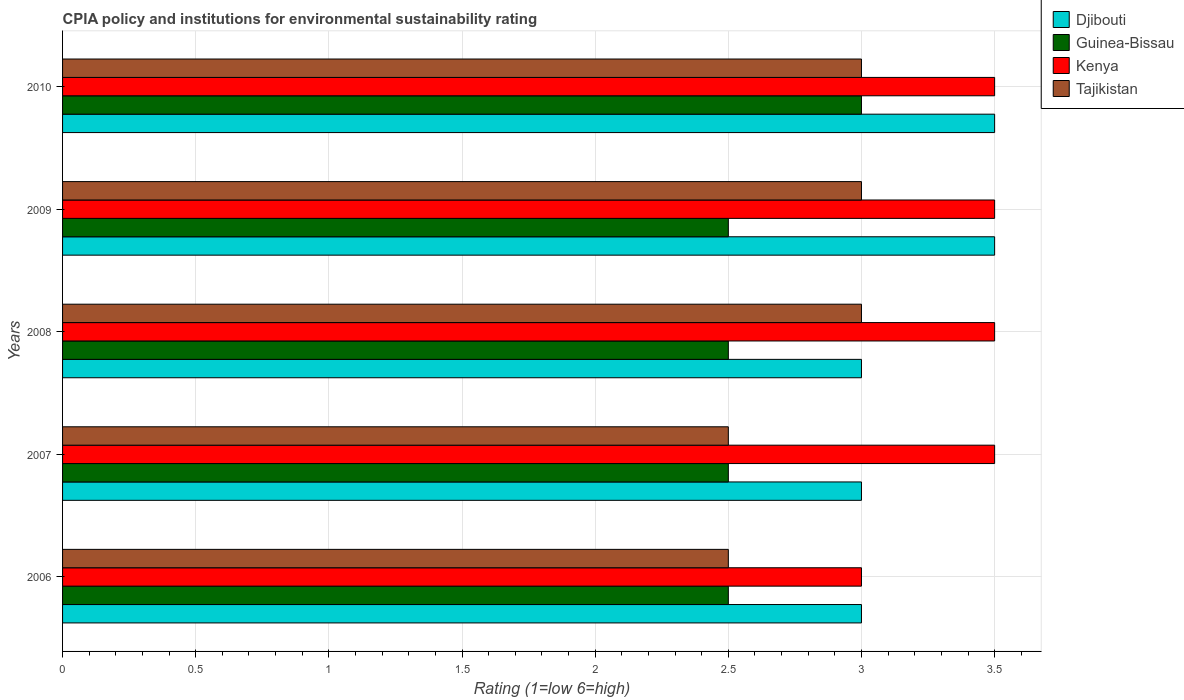How many different coloured bars are there?
Offer a terse response. 4. Are the number of bars per tick equal to the number of legend labels?
Offer a very short reply. Yes. Are the number of bars on each tick of the Y-axis equal?
Provide a succinct answer. Yes. How many bars are there on the 1st tick from the top?
Ensure brevity in your answer.  4. How many bars are there on the 2nd tick from the bottom?
Ensure brevity in your answer.  4. What is the label of the 1st group of bars from the top?
Provide a succinct answer. 2010. What is the CPIA rating in Kenya in 2009?
Your answer should be compact. 3.5. Across all years, what is the maximum CPIA rating in Tajikistan?
Make the answer very short. 3. Is the difference between the CPIA rating in Tajikistan in 2006 and 2007 greater than the difference between the CPIA rating in Guinea-Bissau in 2006 and 2007?
Offer a terse response. No. What is the difference between the highest and the second highest CPIA rating in Tajikistan?
Give a very brief answer. 0. What is the difference between the highest and the lowest CPIA rating in Kenya?
Your answer should be very brief. 0.5. Is it the case that in every year, the sum of the CPIA rating in Tajikistan and CPIA rating in Guinea-Bissau is greater than the sum of CPIA rating in Djibouti and CPIA rating in Kenya?
Provide a succinct answer. No. What does the 4th bar from the top in 2007 represents?
Keep it short and to the point. Djibouti. What does the 1st bar from the bottom in 2007 represents?
Provide a short and direct response. Djibouti. How many bars are there?
Keep it short and to the point. 20. Are all the bars in the graph horizontal?
Offer a terse response. Yes. What is the difference between two consecutive major ticks on the X-axis?
Provide a short and direct response. 0.5. Does the graph contain grids?
Your answer should be very brief. Yes. How many legend labels are there?
Ensure brevity in your answer.  4. How are the legend labels stacked?
Offer a terse response. Vertical. What is the title of the graph?
Offer a terse response. CPIA policy and institutions for environmental sustainability rating. Does "Honduras" appear as one of the legend labels in the graph?
Make the answer very short. No. What is the Rating (1=low 6=high) of Djibouti in 2006?
Your answer should be very brief. 3. What is the Rating (1=low 6=high) of Guinea-Bissau in 2006?
Keep it short and to the point. 2.5. What is the Rating (1=low 6=high) of Kenya in 2006?
Your answer should be compact. 3. What is the Rating (1=low 6=high) of Tajikistan in 2006?
Provide a succinct answer. 2.5. What is the Rating (1=low 6=high) in Djibouti in 2007?
Make the answer very short. 3. What is the Rating (1=low 6=high) in Kenya in 2008?
Offer a very short reply. 3.5. What is the Rating (1=low 6=high) of Kenya in 2009?
Provide a succinct answer. 3.5. What is the Rating (1=low 6=high) of Tajikistan in 2009?
Your response must be concise. 3. What is the Rating (1=low 6=high) in Djibouti in 2010?
Provide a succinct answer. 3.5. What is the Rating (1=low 6=high) of Tajikistan in 2010?
Give a very brief answer. 3. Across all years, what is the maximum Rating (1=low 6=high) in Djibouti?
Provide a short and direct response. 3.5. Across all years, what is the maximum Rating (1=low 6=high) in Guinea-Bissau?
Provide a short and direct response. 3. What is the total Rating (1=low 6=high) in Guinea-Bissau in the graph?
Keep it short and to the point. 13. What is the total Rating (1=low 6=high) of Kenya in the graph?
Ensure brevity in your answer.  17. What is the difference between the Rating (1=low 6=high) of Guinea-Bissau in 2006 and that in 2007?
Give a very brief answer. 0. What is the difference between the Rating (1=low 6=high) of Kenya in 2006 and that in 2007?
Keep it short and to the point. -0.5. What is the difference between the Rating (1=low 6=high) in Tajikistan in 2006 and that in 2007?
Your answer should be very brief. 0. What is the difference between the Rating (1=low 6=high) of Guinea-Bissau in 2006 and that in 2008?
Your answer should be very brief. 0. What is the difference between the Rating (1=low 6=high) in Djibouti in 2006 and that in 2009?
Provide a short and direct response. -0.5. What is the difference between the Rating (1=low 6=high) in Guinea-Bissau in 2006 and that in 2009?
Ensure brevity in your answer.  0. What is the difference between the Rating (1=low 6=high) of Kenya in 2006 and that in 2009?
Your answer should be compact. -0.5. What is the difference between the Rating (1=low 6=high) in Djibouti in 2006 and that in 2010?
Provide a short and direct response. -0.5. What is the difference between the Rating (1=low 6=high) of Kenya in 2006 and that in 2010?
Provide a succinct answer. -0.5. What is the difference between the Rating (1=low 6=high) of Djibouti in 2007 and that in 2009?
Offer a terse response. -0.5. What is the difference between the Rating (1=low 6=high) in Guinea-Bissau in 2007 and that in 2009?
Offer a very short reply. 0. What is the difference between the Rating (1=low 6=high) of Kenya in 2007 and that in 2010?
Provide a succinct answer. 0. What is the difference between the Rating (1=low 6=high) in Guinea-Bissau in 2008 and that in 2009?
Your answer should be very brief. 0. What is the difference between the Rating (1=low 6=high) in Tajikistan in 2008 and that in 2009?
Your answer should be compact. 0. What is the difference between the Rating (1=low 6=high) in Djibouti in 2008 and that in 2010?
Give a very brief answer. -0.5. What is the difference between the Rating (1=low 6=high) of Guinea-Bissau in 2008 and that in 2010?
Offer a terse response. -0.5. What is the difference between the Rating (1=low 6=high) in Tajikistan in 2008 and that in 2010?
Your answer should be compact. 0. What is the difference between the Rating (1=low 6=high) in Djibouti in 2009 and that in 2010?
Provide a short and direct response. 0. What is the difference between the Rating (1=low 6=high) of Guinea-Bissau in 2009 and that in 2010?
Give a very brief answer. -0.5. What is the difference between the Rating (1=low 6=high) in Kenya in 2009 and that in 2010?
Make the answer very short. 0. What is the difference between the Rating (1=low 6=high) in Tajikistan in 2009 and that in 2010?
Your answer should be compact. 0. What is the difference between the Rating (1=low 6=high) in Guinea-Bissau in 2006 and the Rating (1=low 6=high) in Kenya in 2007?
Provide a short and direct response. -1. What is the difference between the Rating (1=low 6=high) of Guinea-Bissau in 2006 and the Rating (1=low 6=high) of Tajikistan in 2007?
Keep it short and to the point. 0. What is the difference between the Rating (1=low 6=high) of Djibouti in 2006 and the Rating (1=low 6=high) of Guinea-Bissau in 2008?
Keep it short and to the point. 0.5. What is the difference between the Rating (1=low 6=high) in Djibouti in 2006 and the Rating (1=low 6=high) in Tajikistan in 2008?
Your answer should be very brief. 0. What is the difference between the Rating (1=low 6=high) of Guinea-Bissau in 2006 and the Rating (1=low 6=high) of Kenya in 2008?
Your answer should be very brief. -1. What is the difference between the Rating (1=low 6=high) of Guinea-Bissau in 2006 and the Rating (1=low 6=high) of Tajikistan in 2008?
Keep it short and to the point. -0.5. What is the difference between the Rating (1=low 6=high) in Djibouti in 2006 and the Rating (1=low 6=high) in Kenya in 2009?
Your answer should be very brief. -0.5. What is the difference between the Rating (1=low 6=high) in Djibouti in 2006 and the Rating (1=low 6=high) in Tajikistan in 2009?
Make the answer very short. 0. What is the difference between the Rating (1=low 6=high) in Guinea-Bissau in 2006 and the Rating (1=low 6=high) in Kenya in 2009?
Keep it short and to the point. -1. What is the difference between the Rating (1=low 6=high) in Kenya in 2006 and the Rating (1=low 6=high) in Tajikistan in 2009?
Your response must be concise. 0. What is the difference between the Rating (1=low 6=high) of Djibouti in 2006 and the Rating (1=low 6=high) of Kenya in 2010?
Provide a succinct answer. -0.5. What is the difference between the Rating (1=low 6=high) of Djibouti in 2006 and the Rating (1=low 6=high) of Tajikistan in 2010?
Offer a very short reply. 0. What is the difference between the Rating (1=low 6=high) of Guinea-Bissau in 2006 and the Rating (1=low 6=high) of Kenya in 2010?
Offer a very short reply. -1. What is the difference between the Rating (1=low 6=high) in Djibouti in 2007 and the Rating (1=low 6=high) in Guinea-Bissau in 2008?
Offer a terse response. 0.5. What is the difference between the Rating (1=low 6=high) of Djibouti in 2007 and the Rating (1=low 6=high) of Kenya in 2008?
Offer a very short reply. -0.5. What is the difference between the Rating (1=low 6=high) in Djibouti in 2007 and the Rating (1=low 6=high) in Tajikistan in 2008?
Provide a succinct answer. 0. What is the difference between the Rating (1=low 6=high) in Guinea-Bissau in 2007 and the Rating (1=low 6=high) in Kenya in 2008?
Offer a very short reply. -1. What is the difference between the Rating (1=low 6=high) in Kenya in 2007 and the Rating (1=low 6=high) in Tajikistan in 2008?
Ensure brevity in your answer.  0.5. What is the difference between the Rating (1=low 6=high) in Djibouti in 2007 and the Rating (1=low 6=high) in Guinea-Bissau in 2009?
Provide a short and direct response. 0.5. What is the difference between the Rating (1=low 6=high) of Djibouti in 2007 and the Rating (1=low 6=high) of Kenya in 2009?
Give a very brief answer. -0.5. What is the difference between the Rating (1=low 6=high) in Guinea-Bissau in 2007 and the Rating (1=low 6=high) in Kenya in 2009?
Your answer should be very brief. -1. What is the difference between the Rating (1=low 6=high) in Kenya in 2007 and the Rating (1=low 6=high) in Tajikistan in 2009?
Ensure brevity in your answer.  0.5. What is the difference between the Rating (1=low 6=high) of Djibouti in 2007 and the Rating (1=low 6=high) of Guinea-Bissau in 2010?
Your answer should be very brief. 0. What is the difference between the Rating (1=low 6=high) in Djibouti in 2007 and the Rating (1=low 6=high) in Kenya in 2010?
Provide a short and direct response. -0.5. What is the difference between the Rating (1=low 6=high) in Djibouti in 2007 and the Rating (1=low 6=high) in Tajikistan in 2010?
Offer a terse response. 0. What is the difference between the Rating (1=low 6=high) of Guinea-Bissau in 2007 and the Rating (1=low 6=high) of Kenya in 2010?
Provide a succinct answer. -1. What is the difference between the Rating (1=low 6=high) in Kenya in 2007 and the Rating (1=low 6=high) in Tajikistan in 2010?
Offer a very short reply. 0.5. What is the difference between the Rating (1=low 6=high) of Djibouti in 2008 and the Rating (1=low 6=high) of Guinea-Bissau in 2009?
Give a very brief answer. 0.5. What is the difference between the Rating (1=low 6=high) in Kenya in 2008 and the Rating (1=low 6=high) in Tajikistan in 2009?
Offer a very short reply. 0.5. What is the difference between the Rating (1=low 6=high) of Djibouti in 2008 and the Rating (1=low 6=high) of Kenya in 2010?
Offer a terse response. -0.5. What is the difference between the Rating (1=low 6=high) in Djibouti in 2008 and the Rating (1=low 6=high) in Tajikistan in 2010?
Give a very brief answer. 0. What is the difference between the Rating (1=low 6=high) of Guinea-Bissau in 2008 and the Rating (1=low 6=high) of Tajikistan in 2010?
Your answer should be very brief. -0.5. What is the difference between the Rating (1=low 6=high) in Djibouti in 2009 and the Rating (1=low 6=high) in Guinea-Bissau in 2010?
Your answer should be compact. 0.5. What is the average Rating (1=low 6=high) in Djibouti per year?
Your answer should be compact. 3.2. What is the average Rating (1=low 6=high) in Kenya per year?
Keep it short and to the point. 3.4. In the year 2006, what is the difference between the Rating (1=low 6=high) of Djibouti and Rating (1=low 6=high) of Guinea-Bissau?
Your answer should be compact. 0.5. In the year 2006, what is the difference between the Rating (1=low 6=high) of Djibouti and Rating (1=low 6=high) of Kenya?
Provide a succinct answer. 0. In the year 2006, what is the difference between the Rating (1=low 6=high) in Djibouti and Rating (1=low 6=high) in Tajikistan?
Your answer should be very brief. 0.5. In the year 2006, what is the difference between the Rating (1=low 6=high) of Guinea-Bissau and Rating (1=low 6=high) of Kenya?
Give a very brief answer. -0.5. In the year 2006, what is the difference between the Rating (1=low 6=high) of Guinea-Bissau and Rating (1=low 6=high) of Tajikistan?
Ensure brevity in your answer.  0. In the year 2006, what is the difference between the Rating (1=low 6=high) of Kenya and Rating (1=low 6=high) of Tajikistan?
Keep it short and to the point. 0.5. In the year 2007, what is the difference between the Rating (1=low 6=high) of Guinea-Bissau and Rating (1=low 6=high) of Kenya?
Your answer should be compact. -1. In the year 2007, what is the difference between the Rating (1=low 6=high) in Guinea-Bissau and Rating (1=low 6=high) in Tajikistan?
Make the answer very short. 0. In the year 2007, what is the difference between the Rating (1=low 6=high) of Kenya and Rating (1=low 6=high) of Tajikistan?
Offer a very short reply. 1. In the year 2008, what is the difference between the Rating (1=low 6=high) of Djibouti and Rating (1=low 6=high) of Guinea-Bissau?
Your response must be concise. 0.5. In the year 2008, what is the difference between the Rating (1=low 6=high) of Djibouti and Rating (1=low 6=high) of Kenya?
Provide a short and direct response. -0.5. In the year 2009, what is the difference between the Rating (1=low 6=high) of Guinea-Bissau and Rating (1=low 6=high) of Kenya?
Offer a very short reply. -1. In the year 2010, what is the difference between the Rating (1=low 6=high) of Djibouti and Rating (1=low 6=high) of Tajikistan?
Offer a terse response. 0.5. In the year 2010, what is the difference between the Rating (1=low 6=high) of Guinea-Bissau and Rating (1=low 6=high) of Tajikistan?
Provide a succinct answer. 0. What is the ratio of the Rating (1=low 6=high) in Tajikistan in 2006 to that in 2008?
Give a very brief answer. 0.83. What is the ratio of the Rating (1=low 6=high) in Guinea-Bissau in 2006 to that in 2009?
Keep it short and to the point. 1. What is the ratio of the Rating (1=low 6=high) in Djibouti in 2006 to that in 2010?
Keep it short and to the point. 0.86. What is the ratio of the Rating (1=low 6=high) of Guinea-Bissau in 2006 to that in 2010?
Offer a terse response. 0.83. What is the ratio of the Rating (1=low 6=high) of Djibouti in 2007 to that in 2008?
Offer a very short reply. 1. What is the ratio of the Rating (1=low 6=high) of Djibouti in 2007 to that in 2009?
Offer a very short reply. 0.86. What is the ratio of the Rating (1=low 6=high) in Kenya in 2007 to that in 2009?
Your answer should be compact. 1. What is the ratio of the Rating (1=low 6=high) in Tajikistan in 2007 to that in 2009?
Make the answer very short. 0.83. What is the ratio of the Rating (1=low 6=high) in Djibouti in 2008 to that in 2009?
Your response must be concise. 0.86. What is the ratio of the Rating (1=low 6=high) in Guinea-Bissau in 2008 to that in 2010?
Your response must be concise. 0.83. What is the ratio of the Rating (1=low 6=high) of Kenya in 2008 to that in 2010?
Give a very brief answer. 1. What is the ratio of the Rating (1=low 6=high) of Tajikistan in 2008 to that in 2010?
Your response must be concise. 1. What is the ratio of the Rating (1=low 6=high) of Kenya in 2009 to that in 2010?
Your answer should be compact. 1. What is the difference between the highest and the second highest Rating (1=low 6=high) in Kenya?
Your answer should be compact. 0. What is the difference between the highest and the second highest Rating (1=low 6=high) of Tajikistan?
Ensure brevity in your answer.  0. What is the difference between the highest and the lowest Rating (1=low 6=high) of Djibouti?
Make the answer very short. 0.5. What is the difference between the highest and the lowest Rating (1=low 6=high) in Guinea-Bissau?
Your answer should be very brief. 0.5. 